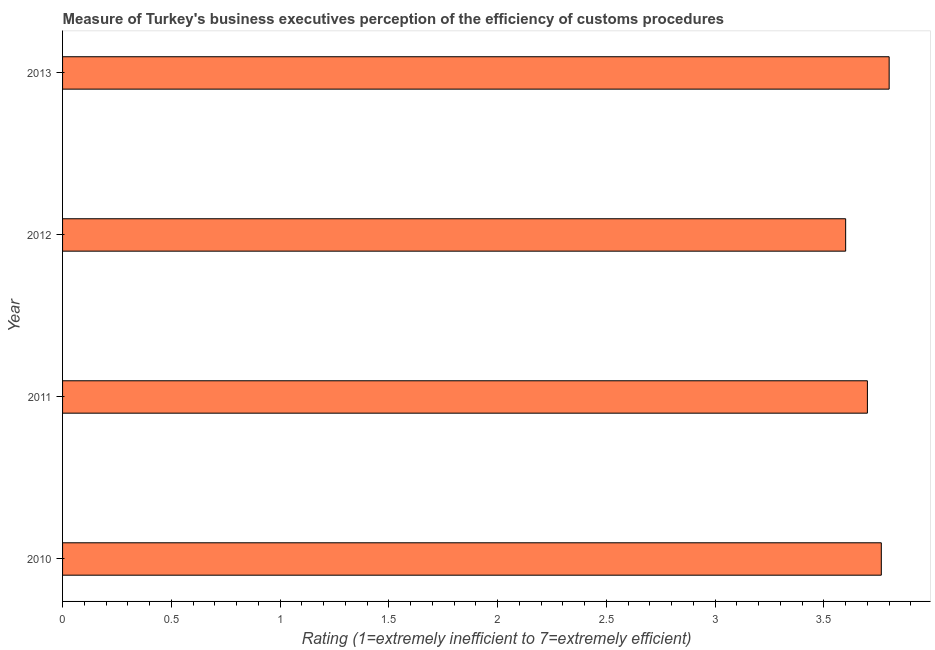What is the title of the graph?
Provide a short and direct response. Measure of Turkey's business executives perception of the efficiency of customs procedures. What is the label or title of the X-axis?
Provide a short and direct response. Rating (1=extremely inefficient to 7=extremely efficient). What is the label or title of the Y-axis?
Your answer should be very brief. Year. What is the rating measuring burden of customs procedure in 2010?
Offer a very short reply. 3.76. In which year was the rating measuring burden of customs procedure maximum?
Your answer should be very brief. 2013. What is the sum of the rating measuring burden of customs procedure?
Offer a terse response. 14.86. What is the average rating measuring burden of customs procedure per year?
Give a very brief answer. 3.72. What is the median rating measuring burden of customs procedure?
Keep it short and to the point. 3.73. What is the ratio of the rating measuring burden of customs procedure in 2010 to that in 2012?
Give a very brief answer. 1.05. What is the difference between the highest and the second highest rating measuring burden of customs procedure?
Make the answer very short. 0.04. Is the sum of the rating measuring burden of customs procedure in 2010 and 2011 greater than the maximum rating measuring burden of customs procedure across all years?
Offer a very short reply. Yes. What is the difference between the highest and the lowest rating measuring burden of customs procedure?
Offer a very short reply. 0.2. How many bars are there?
Offer a very short reply. 4. Are the values on the major ticks of X-axis written in scientific E-notation?
Give a very brief answer. No. What is the Rating (1=extremely inefficient to 7=extremely efficient) in 2010?
Make the answer very short. 3.76. What is the Rating (1=extremely inefficient to 7=extremely efficient) of 2012?
Your answer should be very brief. 3.6. What is the Rating (1=extremely inefficient to 7=extremely efficient) of 2013?
Your answer should be very brief. 3.8. What is the difference between the Rating (1=extremely inefficient to 7=extremely efficient) in 2010 and 2011?
Provide a short and direct response. 0.06. What is the difference between the Rating (1=extremely inefficient to 7=extremely efficient) in 2010 and 2012?
Your answer should be very brief. 0.16. What is the difference between the Rating (1=extremely inefficient to 7=extremely efficient) in 2010 and 2013?
Make the answer very short. -0.04. What is the difference between the Rating (1=extremely inefficient to 7=extremely efficient) in 2011 and 2012?
Provide a succinct answer. 0.1. What is the difference between the Rating (1=extremely inefficient to 7=extremely efficient) in 2011 and 2013?
Ensure brevity in your answer.  -0.1. What is the difference between the Rating (1=extremely inefficient to 7=extremely efficient) in 2012 and 2013?
Your response must be concise. -0.2. What is the ratio of the Rating (1=extremely inefficient to 7=extremely efficient) in 2010 to that in 2011?
Make the answer very short. 1.02. What is the ratio of the Rating (1=extremely inefficient to 7=extremely efficient) in 2010 to that in 2012?
Offer a very short reply. 1.05. What is the ratio of the Rating (1=extremely inefficient to 7=extremely efficient) in 2010 to that in 2013?
Your response must be concise. 0.99. What is the ratio of the Rating (1=extremely inefficient to 7=extremely efficient) in 2011 to that in 2012?
Your answer should be very brief. 1.03. What is the ratio of the Rating (1=extremely inefficient to 7=extremely efficient) in 2012 to that in 2013?
Offer a terse response. 0.95. 